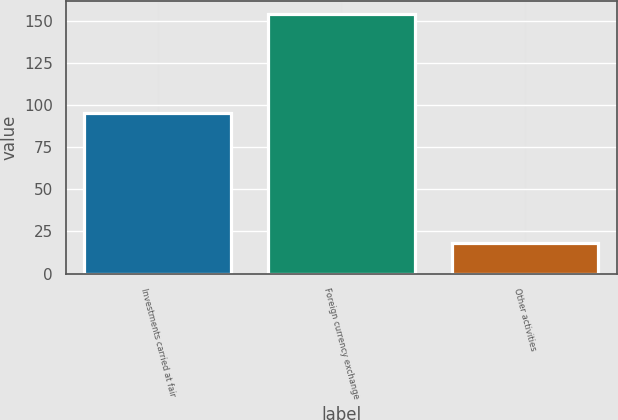Convert chart. <chart><loc_0><loc_0><loc_500><loc_500><bar_chart><fcel>Investments carried at fair<fcel>Foreign currency exchange<fcel>Other activities<nl><fcel>95<fcel>154<fcel>18<nl></chart> 